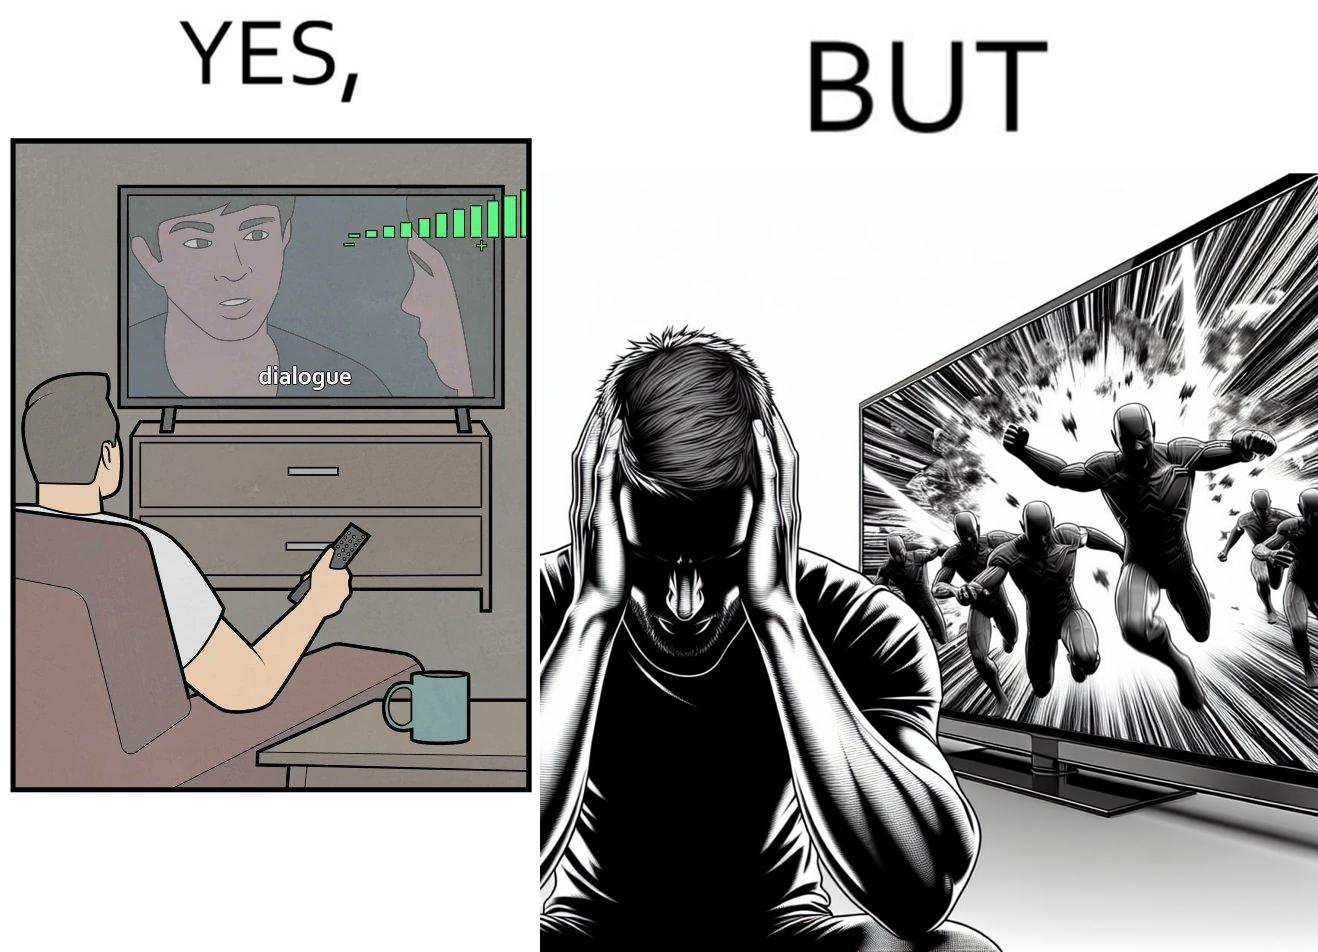Describe the contrast between the left and right parts of this image. In the left part of the image: a person watching TV and increasing the volume of TV, maybe because he is not able to hear the dialogues properly In the right part of the image: a person covering his ears from the loud noise of TV, maybe because of the action scenes 